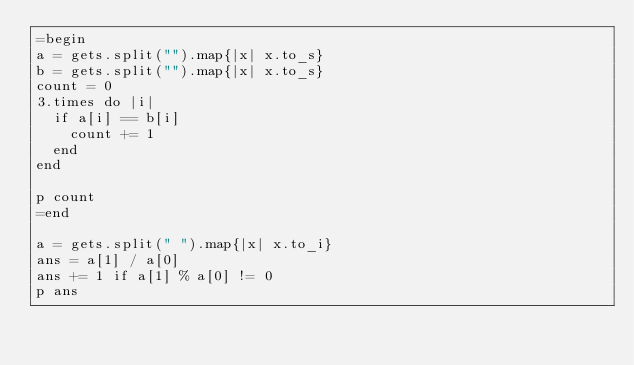<code> <loc_0><loc_0><loc_500><loc_500><_Ruby_>=begin
a = gets.split("").map{|x| x.to_s}
b = gets.split("").map{|x| x.to_s}
count = 0
3.times do |i|
  if a[i] == b[i]
    count += 1
  end
end

p count
=end

a = gets.split(" ").map{|x| x.to_i}
ans = a[1] / a[0]
ans += 1 if a[1] % a[0] != 0
p ans
</code> 